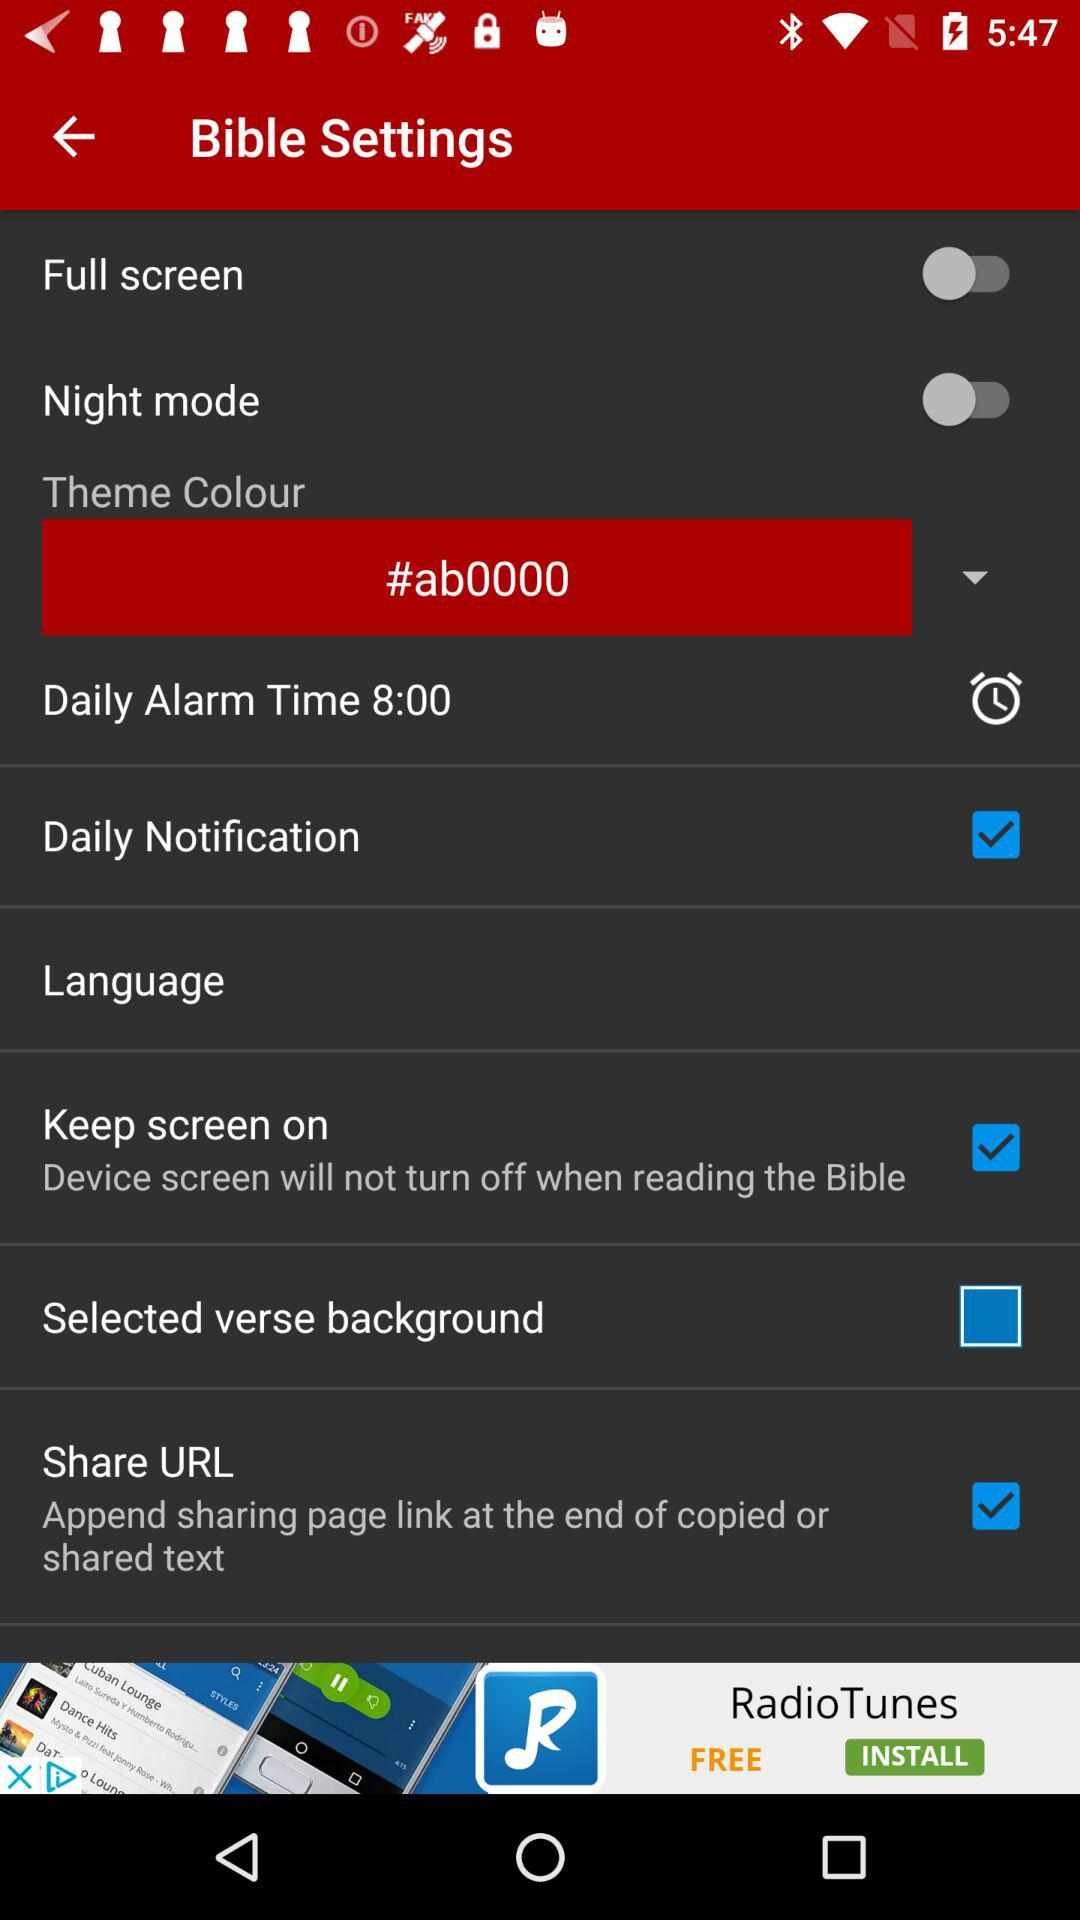Which checkboxes have not been selected? The checkbox that has not been selected is "Selected verse background". 